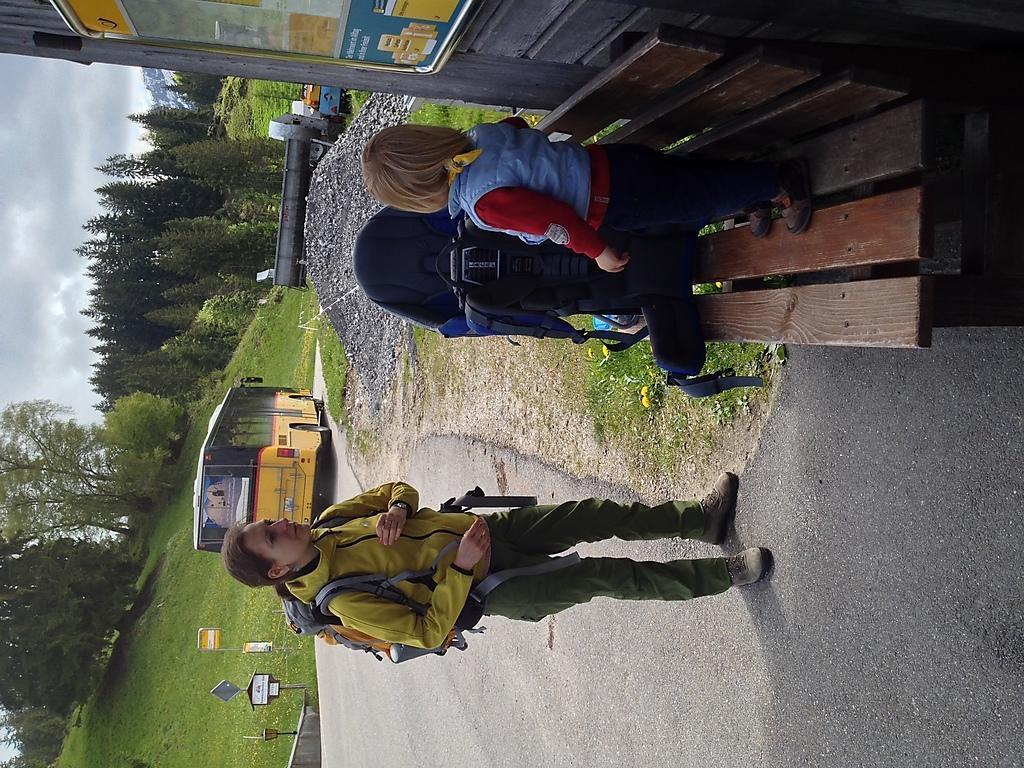How would you summarize this image in a sentence or two? In this image I can see two people with different color dresses and one person with the bag. I can see one person standing on the bench. To the right there is board to the wall. To the left I can see the vehicle on the road. In the background I can see another vehicle, trees and the sky. 